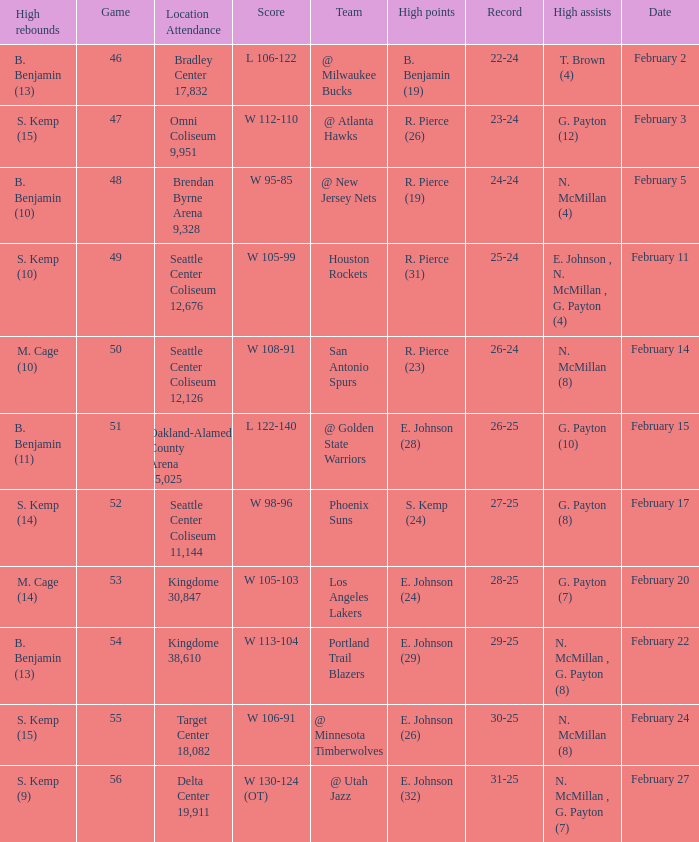Which game had a score of w 95-85? 48.0. 